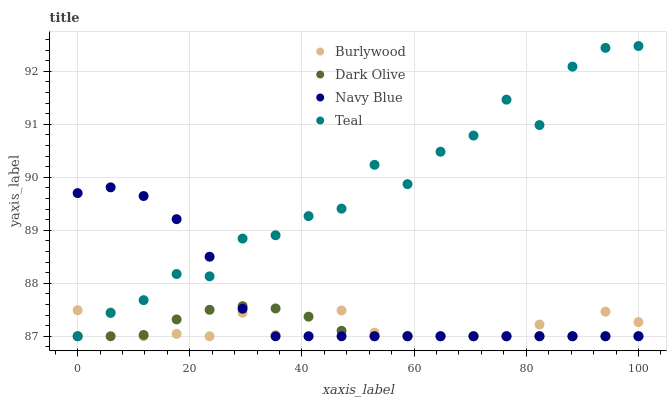Does Dark Olive have the minimum area under the curve?
Answer yes or no. Yes. Does Teal have the maximum area under the curve?
Answer yes or no. Yes. Does Navy Blue have the minimum area under the curve?
Answer yes or no. No. Does Navy Blue have the maximum area under the curve?
Answer yes or no. No. Is Dark Olive the smoothest?
Answer yes or no. Yes. Is Teal the roughest?
Answer yes or no. Yes. Is Navy Blue the smoothest?
Answer yes or no. No. Is Navy Blue the roughest?
Answer yes or no. No. Does Burlywood have the lowest value?
Answer yes or no. Yes. Does Teal have the highest value?
Answer yes or no. Yes. Does Navy Blue have the highest value?
Answer yes or no. No. Does Navy Blue intersect Burlywood?
Answer yes or no. Yes. Is Navy Blue less than Burlywood?
Answer yes or no. No. Is Navy Blue greater than Burlywood?
Answer yes or no. No. 